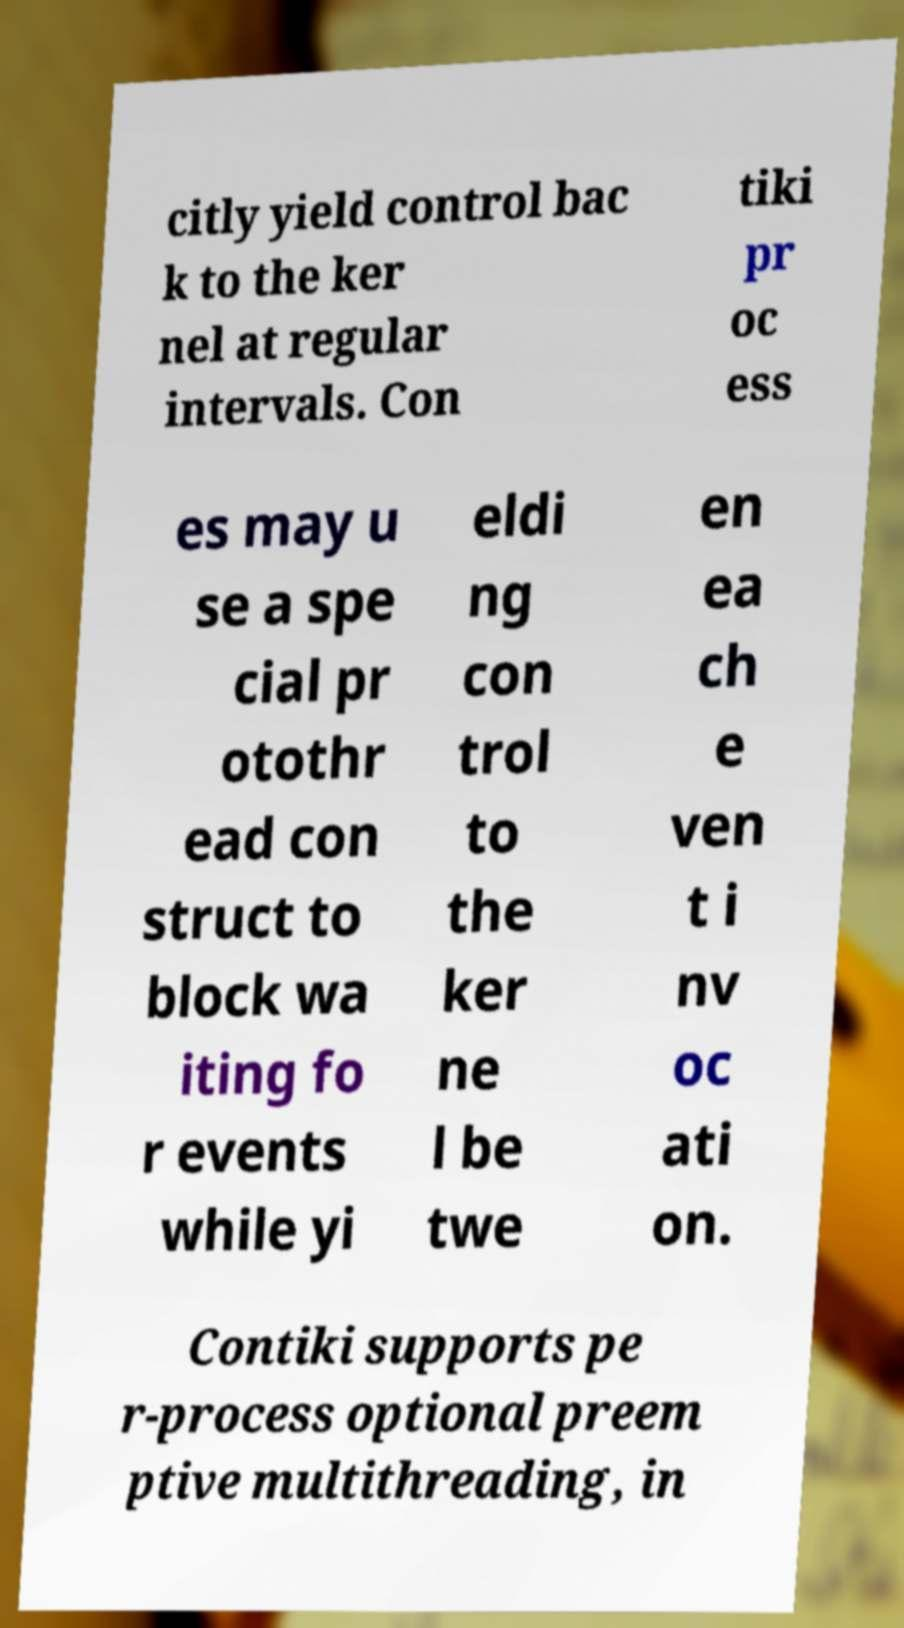There's text embedded in this image that I need extracted. Can you transcribe it verbatim? citly yield control bac k to the ker nel at regular intervals. Con tiki pr oc ess es may u se a spe cial pr otothr ead con struct to block wa iting fo r events while yi eldi ng con trol to the ker ne l be twe en ea ch e ven t i nv oc ati on. Contiki supports pe r-process optional preem ptive multithreading, in 